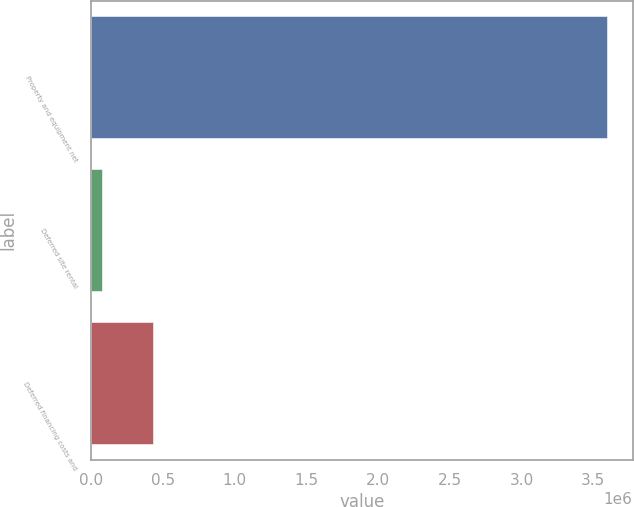Convert chart. <chart><loc_0><loc_0><loc_500><loc_500><bar_chart><fcel>Property and equipment net<fcel>Deferred site rental<fcel>Deferred financing costs and<nl><fcel>3.59357e+06<fcel>76333<fcel>428057<nl></chart> 